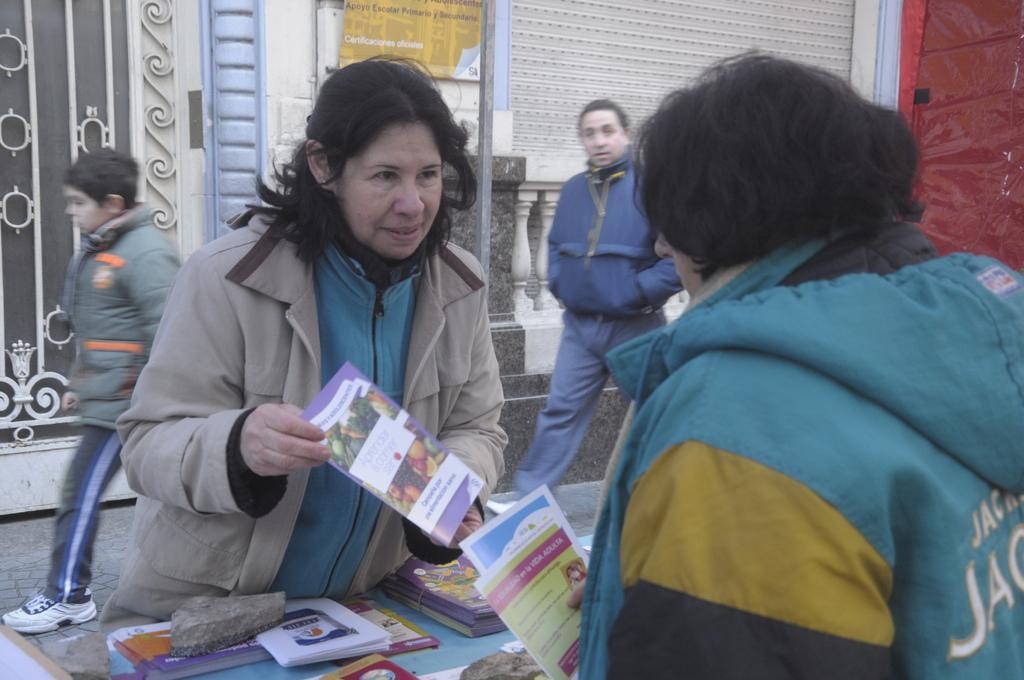Describe this image in one or two sentences. In front of the image there are two persons standing and holding pamphlets in their hands. In the middle of them there is a table with pamphlets and stones. In the background there are two persons walking. Behind them there is a wall with a gate, poster and some other things. 